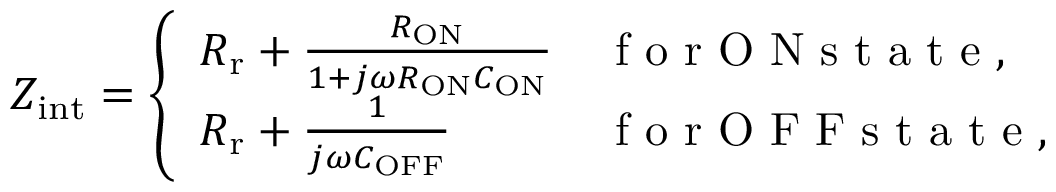Convert formula to latex. <formula><loc_0><loc_0><loc_500><loc_500>Z _ { i n t } = \left \{ \begin{array} { l l } { R _ { r } + \frac { R _ { O N } } { 1 + j \omega R _ { O N } C _ { O N } } } & { f o r O N s t a t e , } \\ { R _ { r } + \frac { 1 } { j \omega C _ { O F F } } } & { f o r O F F s t a t e , } \end{array}</formula> 